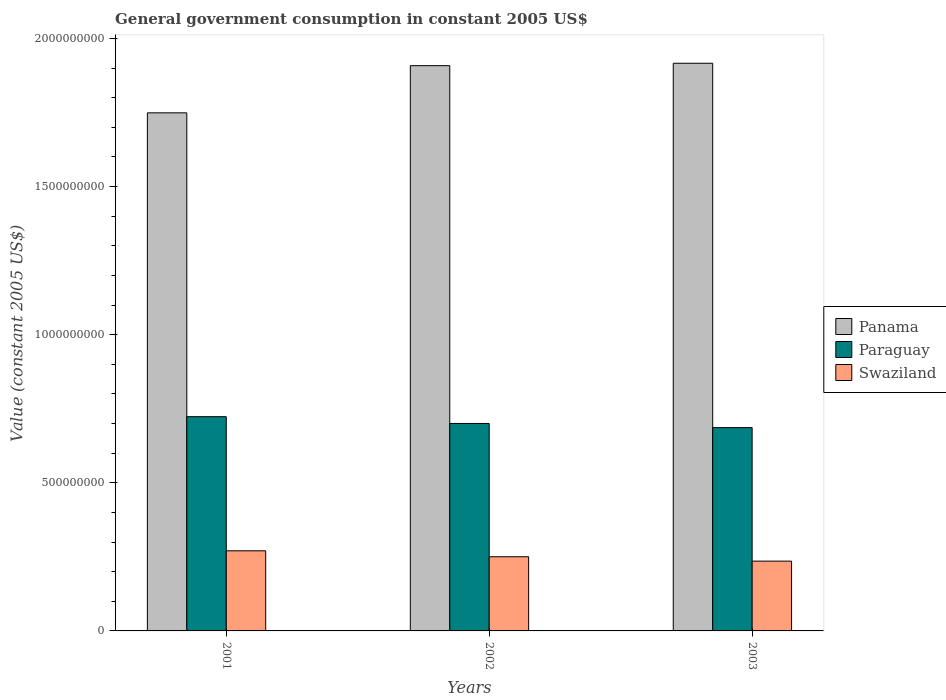How many different coloured bars are there?
Provide a succinct answer. 3. What is the government conusmption in Swaziland in 2002?
Ensure brevity in your answer.  2.50e+08. Across all years, what is the maximum government conusmption in Paraguay?
Provide a short and direct response. 7.23e+08. Across all years, what is the minimum government conusmption in Swaziland?
Your response must be concise. 2.36e+08. In which year was the government conusmption in Panama maximum?
Provide a succinct answer. 2003. In which year was the government conusmption in Paraguay minimum?
Provide a succinct answer. 2003. What is the total government conusmption in Panama in the graph?
Ensure brevity in your answer.  5.57e+09. What is the difference between the government conusmption in Panama in 2002 and that in 2003?
Your response must be concise. -8.15e+06. What is the difference between the government conusmption in Swaziland in 2001 and the government conusmption in Panama in 2002?
Keep it short and to the point. -1.64e+09. What is the average government conusmption in Swaziland per year?
Provide a short and direct response. 2.52e+08. In the year 2003, what is the difference between the government conusmption in Panama and government conusmption in Swaziland?
Offer a terse response. 1.68e+09. In how many years, is the government conusmption in Panama greater than 1100000000 US$?
Ensure brevity in your answer.  3. What is the ratio of the government conusmption in Swaziland in 2001 to that in 2003?
Offer a terse response. 1.15. Is the government conusmption in Swaziland in 2002 less than that in 2003?
Make the answer very short. No. Is the difference between the government conusmption in Panama in 2001 and 2003 greater than the difference between the government conusmption in Swaziland in 2001 and 2003?
Your answer should be very brief. No. What is the difference between the highest and the second highest government conusmption in Paraguay?
Your response must be concise. 2.29e+07. What is the difference between the highest and the lowest government conusmption in Swaziland?
Provide a succinct answer. 3.49e+07. Is the sum of the government conusmption in Panama in 2001 and 2002 greater than the maximum government conusmption in Swaziland across all years?
Your answer should be very brief. Yes. What does the 2nd bar from the left in 2003 represents?
Your response must be concise. Paraguay. What does the 2nd bar from the right in 2003 represents?
Give a very brief answer. Paraguay. Is it the case that in every year, the sum of the government conusmption in Swaziland and government conusmption in Paraguay is greater than the government conusmption in Panama?
Ensure brevity in your answer.  No. How many years are there in the graph?
Offer a terse response. 3. Does the graph contain grids?
Your response must be concise. No. Where does the legend appear in the graph?
Provide a succinct answer. Center right. How are the legend labels stacked?
Your response must be concise. Vertical. What is the title of the graph?
Provide a short and direct response. General government consumption in constant 2005 US$. Does "Samoa" appear as one of the legend labels in the graph?
Give a very brief answer. No. What is the label or title of the X-axis?
Give a very brief answer. Years. What is the label or title of the Y-axis?
Make the answer very short. Value (constant 2005 US$). What is the Value (constant 2005 US$) of Panama in 2001?
Make the answer very short. 1.75e+09. What is the Value (constant 2005 US$) in Paraguay in 2001?
Give a very brief answer. 7.23e+08. What is the Value (constant 2005 US$) of Swaziland in 2001?
Offer a very short reply. 2.70e+08. What is the Value (constant 2005 US$) in Panama in 2002?
Offer a terse response. 1.91e+09. What is the Value (constant 2005 US$) in Paraguay in 2002?
Your response must be concise. 7.00e+08. What is the Value (constant 2005 US$) of Swaziland in 2002?
Make the answer very short. 2.50e+08. What is the Value (constant 2005 US$) in Panama in 2003?
Your answer should be compact. 1.92e+09. What is the Value (constant 2005 US$) in Paraguay in 2003?
Your answer should be very brief. 6.86e+08. What is the Value (constant 2005 US$) of Swaziland in 2003?
Make the answer very short. 2.36e+08. Across all years, what is the maximum Value (constant 2005 US$) in Panama?
Ensure brevity in your answer.  1.92e+09. Across all years, what is the maximum Value (constant 2005 US$) of Paraguay?
Your answer should be very brief. 7.23e+08. Across all years, what is the maximum Value (constant 2005 US$) in Swaziland?
Offer a terse response. 2.70e+08. Across all years, what is the minimum Value (constant 2005 US$) of Panama?
Keep it short and to the point. 1.75e+09. Across all years, what is the minimum Value (constant 2005 US$) of Paraguay?
Offer a terse response. 6.86e+08. Across all years, what is the minimum Value (constant 2005 US$) in Swaziland?
Keep it short and to the point. 2.36e+08. What is the total Value (constant 2005 US$) in Panama in the graph?
Make the answer very short. 5.57e+09. What is the total Value (constant 2005 US$) of Paraguay in the graph?
Your response must be concise. 2.11e+09. What is the total Value (constant 2005 US$) of Swaziland in the graph?
Offer a terse response. 7.56e+08. What is the difference between the Value (constant 2005 US$) of Panama in 2001 and that in 2002?
Provide a short and direct response. -1.59e+08. What is the difference between the Value (constant 2005 US$) of Paraguay in 2001 and that in 2002?
Offer a terse response. 2.29e+07. What is the difference between the Value (constant 2005 US$) in Swaziland in 2001 and that in 2002?
Provide a short and direct response. 2.01e+07. What is the difference between the Value (constant 2005 US$) in Panama in 2001 and that in 2003?
Your answer should be compact. -1.67e+08. What is the difference between the Value (constant 2005 US$) of Paraguay in 2001 and that in 2003?
Ensure brevity in your answer.  3.69e+07. What is the difference between the Value (constant 2005 US$) of Swaziland in 2001 and that in 2003?
Offer a very short reply. 3.49e+07. What is the difference between the Value (constant 2005 US$) of Panama in 2002 and that in 2003?
Provide a succinct answer. -8.15e+06. What is the difference between the Value (constant 2005 US$) of Paraguay in 2002 and that in 2003?
Provide a succinct answer. 1.40e+07. What is the difference between the Value (constant 2005 US$) of Swaziland in 2002 and that in 2003?
Your answer should be very brief. 1.48e+07. What is the difference between the Value (constant 2005 US$) in Panama in 2001 and the Value (constant 2005 US$) in Paraguay in 2002?
Keep it short and to the point. 1.05e+09. What is the difference between the Value (constant 2005 US$) of Panama in 2001 and the Value (constant 2005 US$) of Swaziland in 2002?
Offer a very short reply. 1.50e+09. What is the difference between the Value (constant 2005 US$) in Paraguay in 2001 and the Value (constant 2005 US$) in Swaziland in 2002?
Provide a short and direct response. 4.73e+08. What is the difference between the Value (constant 2005 US$) of Panama in 2001 and the Value (constant 2005 US$) of Paraguay in 2003?
Keep it short and to the point. 1.06e+09. What is the difference between the Value (constant 2005 US$) of Panama in 2001 and the Value (constant 2005 US$) of Swaziland in 2003?
Make the answer very short. 1.51e+09. What is the difference between the Value (constant 2005 US$) of Paraguay in 2001 and the Value (constant 2005 US$) of Swaziland in 2003?
Your response must be concise. 4.88e+08. What is the difference between the Value (constant 2005 US$) in Panama in 2002 and the Value (constant 2005 US$) in Paraguay in 2003?
Ensure brevity in your answer.  1.22e+09. What is the difference between the Value (constant 2005 US$) of Panama in 2002 and the Value (constant 2005 US$) of Swaziland in 2003?
Provide a short and direct response. 1.67e+09. What is the difference between the Value (constant 2005 US$) in Paraguay in 2002 and the Value (constant 2005 US$) in Swaziland in 2003?
Offer a very short reply. 4.65e+08. What is the average Value (constant 2005 US$) in Panama per year?
Provide a short and direct response. 1.86e+09. What is the average Value (constant 2005 US$) in Paraguay per year?
Your answer should be compact. 7.03e+08. What is the average Value (constant 2005 US$) of Swaziland per year?
Make the answer very short. 2.52e+08. In the year 2001, what is the difference between the Value (constant 2005 US$) in Panama and Value (constant 2005 US$) in Paraguay?
Make the answer very short. 1.03e+09. In the year 2001, what is the difference between the Value (constant 2005 US$) of Panama and Value (constant 2005 US$) of Swaziland?
Your response must be concise. 1.48e+09. In the year 2001, what is the difference between the Value (constant 2005 US$) of Paraguay and Value (constant 2005 US$) of Swaziland?
Ensure brevity in your answer.  4.53e+08. In the year 2002, what is the difference between the Value (constant 2005 US$) in Panama and Value (constant 2005 US$) in Paraguay?
Offer a very short reply. 1.21e+09. In the year 2002, what is the difference between the Value (constant 2005 US$) in Panama and Value (constant 2005 US$) in Swaziland?
Offer a very short reply. 1.66e+09. In the year 2002, what is the difference between the Value (constant 2005 US$) of Paraguay and Value (constant 2005 US$) of Swaziland?
Your answer should be very brief. 4.50e+08. In the year 2003, what is the difference between the Value (constant 2005 US$) of Panama and Value (constant 2005 US$) of Paraguay?
Ensure brevity in your answer.  1.23e+09. In the year 2003, what is the difference between the Value (constant 2005 US$) of Panama and Value (constant 2005 US$) of Swaziland?
Your response must be concise. 1.68e+09. In the year 2003, what is the difference between the Value (constant 2005 US$) of Paraguay and Value (constant 2005 US$) of Swaziland?
Your response must be concise. 4.51e+08. What is the ratio of the Value (constant 2005 US$) in Panama in 2001 to that in 2002?
Provide a short and direct response. 0.92. What is the ratio of the Value (constant 2005 US$) in Paraguay in 2001 to that in 2002?
Provide a short and direct response. 1.03. What is the ratio of the Value (constant 2005 US$) in Swaziland in 2001 to that in 2002?
Your answer should be very brief. 1.08. What is the ratio of the Value (constant 2005 US$) in Panama in 2001 to that in 2003?
Your answer should be compact. 0.91. What is the ratio of the Value (constant 2005 US$) of Paraguay in 2001 to that in 2003?
Your answer should be very brief. 1.05. What is the ratio of the Value (constant 2005 US$) in Swaziland in 2001 to that in 2003?
Provide a succinct answer. 1.15. What is the ratio of the Value (constant 2005 US$) of Panama in 2002 to that in 2003?
Provide a succinct answer. 1. What is the ratio of the Value (constant 2005 US$) in Paraguay in 2002 to that in 2003?
Offer a very short reply. 1.02. What is the ratio of the Value (constant 2005 US$) of Swaziland in 2002 to that in 2003?
Ensure brevity in your answer.  1.06. What is the difference between the highest and the second highest Value (constant 2005 US$) in Panama?
Make the answer very short. 8.15e+06. What is the difference between the highest and the second highest Value (constant 2005 US$) in Paraguay?
Offer a very short reply. 2.29e+07. What is the difference between the highest and the second highest Value (constant 2005 US$) in Swaziland?
Make the answer very short. 2.01e+07. What is the difference between the highest and the lowest Value (constant 2005 US$) in Panama?
Offer a very short reply. 1.67e+08. What is the difference between the highest and the lowest Value (constant 2005 US$) in Paraguay?
Your answer should be very brief. 3.69e+07. What is the difference between the highest and the lowest Value (constant 2005 US$) of Swaziland?
Provide a succinct answer. 3.49e+07. 